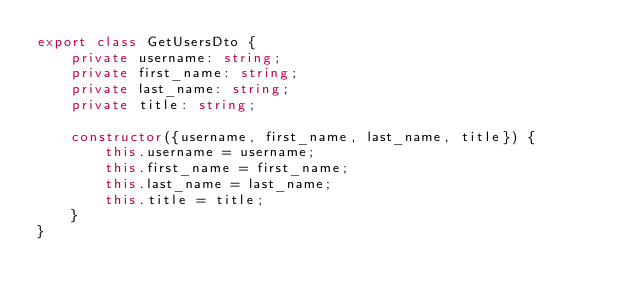Convert code to text. <code><loc_0><loc_0><loc_500><loc_500><_TypeScript_>export class GetUsersDto {
    private username: string;
    private first_name: string;
    private last_name: string;
    private title: string;
    
    constructor({username, first_name, last_name, title}) {
        this.username = username;
        this.first_name = first_name;
        this.last_name = last_name;
        this.title = title; 
    }
}</code> 